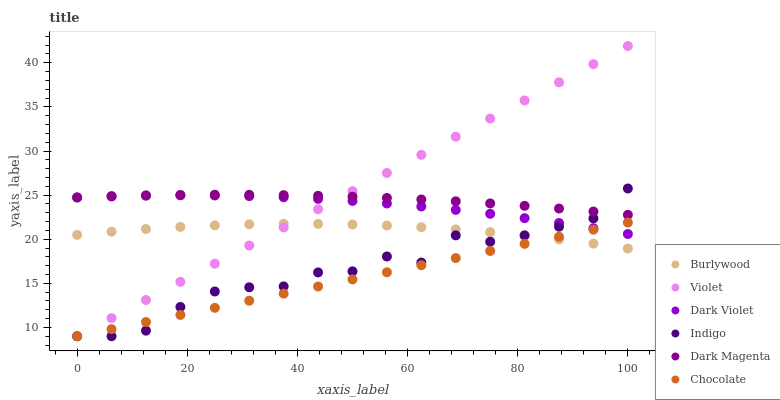Does Chocolate have the minimum area under the curve?
Answer yes or no. Yes. Does Violet have the maximum area under the curve?
Answer yes or no. Yes. Does Dark Magenta have the minimum area under the curve?
Answer yes or no. No. Does Dark Magenta have the maximum area under the curve?
Answer yes or no. No. Is Chocolate the smoothest?
Answer yes or no. Yes. Is Indigo the roughest?
Answer yes or no. Yes. Is Dark Magenta the smoothest?
Answer yes or no. No. Is Dark Magenta the roughest?
Answer yes or no. No. Does Indigo have the lowest value?
Answer yes or no. Yes. Does Burlywood have the lowest value?
Answer yes or no. No. Does Violet have the highest value?
Answer yes or no. Yes. Does Dark Magenta have the highest value?
Answer yes or no. No. Is Burlywood less than Dark Violet?
Answer yes or no. Yes. Is Dark Magenta greater than Chocolate?
Answer yes or no. Yes. Does Dark Magenta intersect Indigo?
Answer yes or no. Yes. Is Dark Magenta less than Indigo?
Answer yes or no. No. Is Dark Magenta greater than Indigo?
Answer yes or no. No. Does Burlywood intersect Dark Violet?
Answer yes or no. No. 